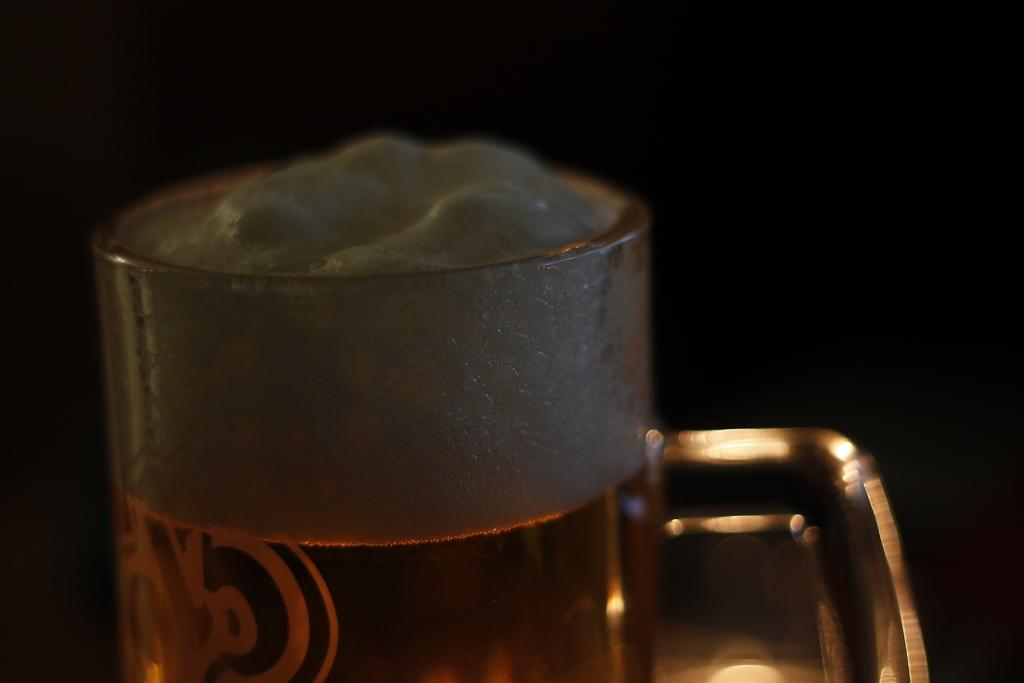What object is present in the image that can hold a liquid? There is a glass in the image. What is inside the glass? The glass contains a liquid. Can you describe the appearance of the liquid in the glass? The liquid in the glass has foam on it. What can be observed about the background of the image? The background of the image is dark. What is the man teaching the ants in the image? There is no man or ants present in the image. How does the learning process take place in the image? There is no learning process depicted in the image. 